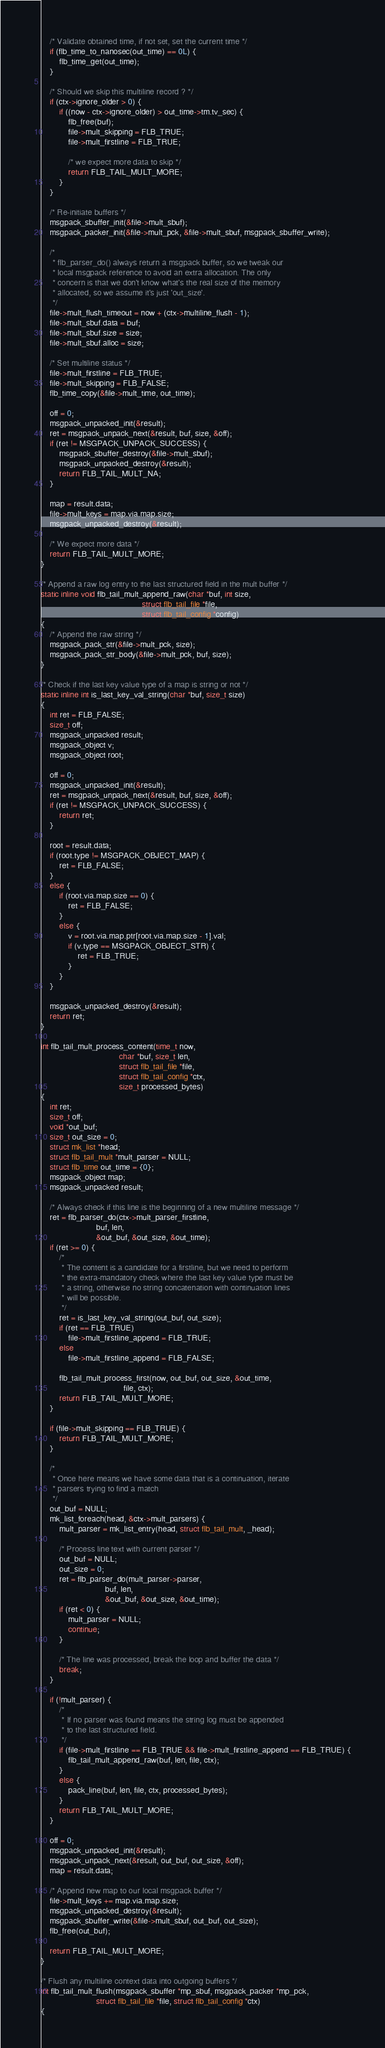Convert code to text. <code><loc_0><loc_0><loc_500><loc_500><_C_>
    /* Validate obtained time, if not set, set the current time */
    if (flb_time_to_nanosec(out_time) == 0L) {
        flb_time_get(out_time);
    }

    /* Should we skip this multiline record ? */
    if (ctx->ignore_older > 0) {
        if ((now - ctx->ignore_older) > out_time->tm.tv_sec) {
            flb_free(buf);
            file->mult_skipping = FLB_TRUE;
            file->mult_firstline = FLB_TRUE;

            /* we expect more data to skip */
            return FLB_TAIL_MULT_MORE;
        }
    }

    /* Re-initiate buffers */
    msgpack_sbuffer_init(&file->mult_sbuf);
    msgpack_packer_init(&file->mult_pck, &file->mult_sbuf, msgpack_sbuffer_write);

    /*
     * flb_parser_do() always return a msgpack buffer, so we tweak our
     * local msgpack reference to avoid an extra allocation. The only
     * concern is that we don't know what's the real size of the memory
     * allocated, so we assume it's just 'out_size'.
     */
    file->mult_flush_timeout = now + (ctx->multiline_flush - 1);
    file->mult_sbuf.data = buf;
    file->mult_sbuf.size = size;
    file->mult_sbuf.alloc = size;

    /* Set multiline status */
    file->mult_firstline = FLB_TRUE;
    file->mult_skipping = FLB_FALSE;
    flb_time_copy(&file->mult_time, out_time);

    off = 0;
    msgpack_unpacked_init(&result);
    ret = msgpack_unpack_next(&result, buf, size, &off);
    if (ret != MSGPACK_UNPACK_SUCCESS) {
        msgpack_sbuffer_destroy(&file->mult_sbuf);
        msgpack_unpacked_destroy(&result);
        return FLB_TAIL_MULT_NA;
    }

    map = result.data;
    file->mult_keys = map.via.map.size;
    msgpack_unpacked_destroy(&result);

    /* We expect more data */
    return FLB_TAIL_MULT_MORE;
}

/* Append a raw log entry to the last structured field in the mult buffer */
static inline void flb_tail_mult_append_raw(char *buf, int size,
                                            struct flb_tail_file *file,
                                            struct flb_tail_config *config)
{
    /* Append the raw string */
    msgpack_pack_str(&file->mult_pck, size);
    msgpack_pack_str_body(&file->mult_pck, buf, size);
}

/* Check if the last key value type of a map is string or not */
static inline int is_last_key_val_string(char *buf, size_t size)
{
    int ret = FLB_FALSE;
    size_t off;
    msgpack_unpacked result;
    msgpack_object v;
    msgpack_object root;

    off = 0;
    msgpack_unpacked_init(&result);
    ret = msgpack_unpack_next(&result, buf, size, &off);
    if (ret != MSGPACK_UNPACK_SUCCESS) {
        return ret;
    }

    root = result.data;
    if (root.type != MSGPACK_OBJECT_MAP) {
        ret = FLB_FALSE;
    }
    else {
        if (root.via.map.size == 0) {
            ret = FLB_FALSE;
        }
        else {
            v = root.via.map.ptr[root.via.map.size - 1].val;
            if (v.type == MSGPACK_OBJECT_STR) {
                ret = FLB_TRUE;
            }
        }
    }

    msgpack_unpacked_destroy(&result);
    return ret;
}

int flb_tail_mult_process_content(time_t now,
                                  char *buf, size_t len,
                                  struct flb_tail_file *file,
                                  struct flb_tail_config *ctx,
                                  size_t processed_bytes)
{
    int ret;
    size_t off;
    void *out_buf;
    size_t out_size = 0;
    struct mk_list *head;
    struct flb_tail_mult *mult_parser = NULL;
    struct flb_time out_time = {0};
    msgpack_object map;
    msgpack_unpacked result;

    /* Always check if this line is the beginning of a new multiline message */
    ret = flb_parser_do(ctx->mult_parser_firstline,
                        buf, len,
                        &out_buf, &out_size, &out_time);
    if (ret >= 0) {
        /*
         * The content is a candidate for a firstline, but we need to perform
         * the extra-mandatory check where the last key value type must be
         * a string, otherwise no string concatenation with continuation lines
         * will be possible.
         */
        ret = is_last_key_val_string(out_buf, out_size);
        if (ret == FLB_TRUE)
            file->mult_firstline_append = FLB_TRUE;
        else
            file->mult_firstline_append = FLB_FALSE;

        flb_tail_mult_process_first(now, out_buf, out_size, &out_time,
                                    file, ctx);
        return FLB_TAIL_MULT_MORE;
    }

    if (file->mult_skipping == FLB_TRUE) {
        return FLB_TAIL_MULT_MORE;
    }

    /*
     * Once here means we have some data that is a continuation, iterate
     * parsers trying to find a match
     */
    out_buf = NULL;
    mk_list_foreach(head, &ctx->mult_parsers) {
        mult_parser = mk_list_entry(head, struct flb_tail_mult, _head);

        /* Process line text with current parser */
        out_buf = NULL;
        out_size = 0;
        ret = flb_parser_do(mult_parser->parser,
                            buf, len,
                            &out_buf, &out_size, &out_time);
        if (ret < 0) {
            mult_parser = NULL;
            continue;
        }

        /* The line was processed, break the loop and buffer the data */
        break;
    }

    if (!mult_parser) {
        /*
         * If no parser was found means the string log must be appended
         * to the last structured field.
         */
        if (file->mult_firstline == FLB_TRUE && file->mult_firstline_append == FLB_TRUE) {
            flb_tail_mult_append_raw(buf, len, file, ctx);
        }
        else {
            pack_line(buf, len, file, ctx, processed_bytes);
        }
        return FLB_TAIL_MULT_MORE;
    }

    off = 0;
    msgpack_unpacked_init(&result);
    msgpack_unpack_next(&result, out_buf, out_size, &off);
    map = result.data;

    /* Append new map to our local msgpack buffer */
    file->mult_keys += map.via.map.size;
    msgpack_unpacked_destroy(&result);
    msgpack_sbuffer_write(&file->mult_sbuf, out_buf, out_size);
    flb_free(out_buf);

    return FLB_TAIL_MULT_MORE;
}

/* Flush any multiline context data into outgoing buffers */
int flb_tail_mult_flush(msgpack_sbuffer *mp_sbuf, msgpack_packer *mp_pck,
                        struct flb_tail_file *file, struct flb_tail_config *ctx)
{</code> 